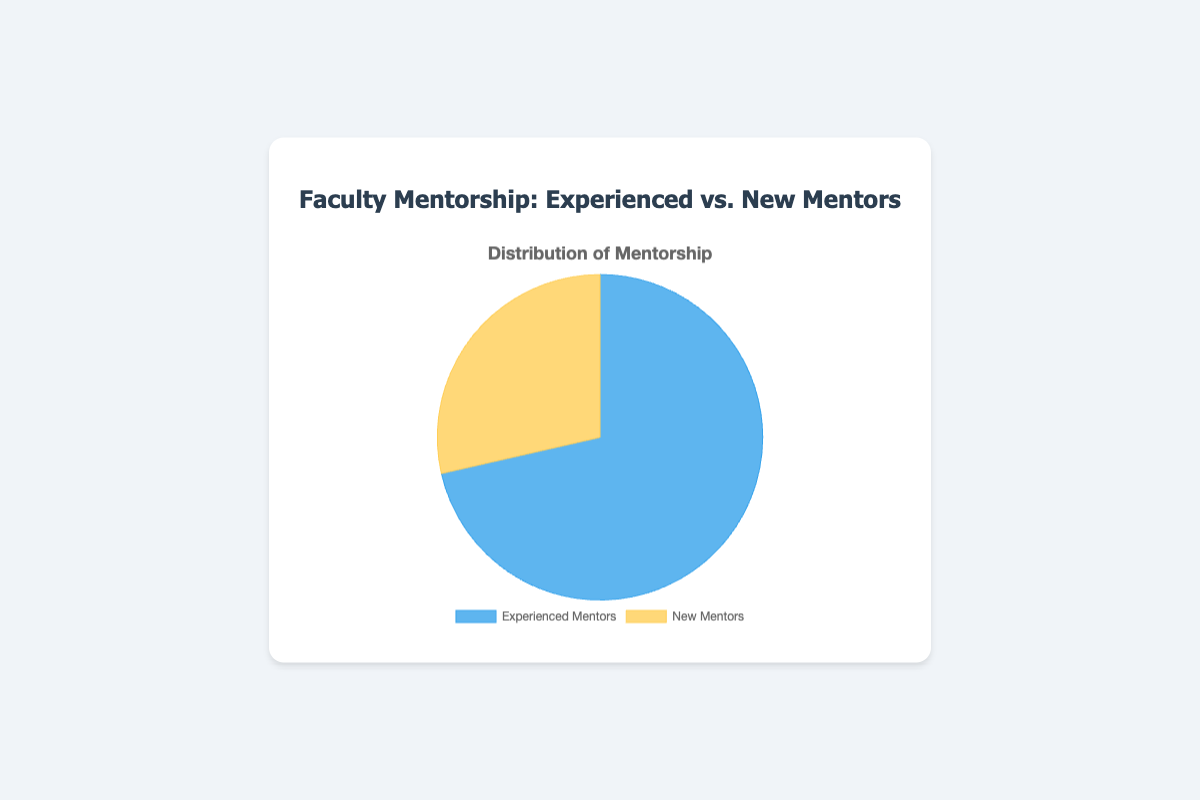What is the percentage of Experienced Mentors in the pie chart? The pie chart shows two categories, Experienced Mentors and New Mentors. The data points indicate that Experienced Mentors total 75, and New Mentors total 30. To find the percentage of Experienced Mentors, calculate (75 / (75 + 30)) * 100.
Answer: 71.43% What is the percentage of New Mentors in the pie chart? The pie chart shows two categories, Experienced Mentors and New Mentors. The data points indicate that Experienced Mentors total 75, and New Mentors total 30. To find the percentage of New Mentors, calculate (30 / (75 + 30)) * 100.
Answer: 28.57% Which category has a larger share, Experienced Mentors or New Mentors? By observing the slices of the pie chart, the slice for Experienced Mentors is visibly larger than the slice for New Mentors. The percentage calculations also confirm this: 71.43% for Experienced Mentors versus 28.57% for New Mentors.
Answer: Experienced Mentors By how much does the number of mentored students differ between Experienced and New Mentors? The pie chart indicates that Experienced Mentors account for 75 mentored students and New Mentors account for 30 mentored students. The difference is 75 - 30.
Answer: 45 What is the total number of mentored students represented in the pie chart? To find the total number of mentored students, sum the values for Experienced Mentors and New Mentors: 75 + 30.
Answer: 105 What color represents Experienced Mentors on the pie chart? The pie chart legend indicates that Experienced Mentors are represented by the color blue.
Answer: Blue What color represents New Mentors on the pie chart? The pie chart legend indicates that New Mentors are represented by the color yellow.
Answer: Yellow How many more students do Experienced Mentors mentor compared to New Mentors? According to the pie chart, Experienced Mentors mentor 75 students while New Mentors mentor 30. The difference is 75 - 30.
Answer: 45 What is the average number of students per mentor in each category? For Experienced Mentors, there are 3 mentors (Dr. Sarah Johnson, Professor Alan Blake, Dr. Emily Carter) and 75 students. The average is 75 / 3. For New Mentors, there are 3 mentors (Assistant Professor Michael Xu, Dr. Rachel Green, Lecturer Chris Patel) and 30 students. The average is 30 / 3.
Answer: Experienced Mentors: 25, New Mentors: 10 Which pie chart segment has the smallest share? By observing the slices in the pie chart, the New Mentors segment is smaller than the Experienced Mentors segment, making it the smallest share.
Answer: New Mentors 